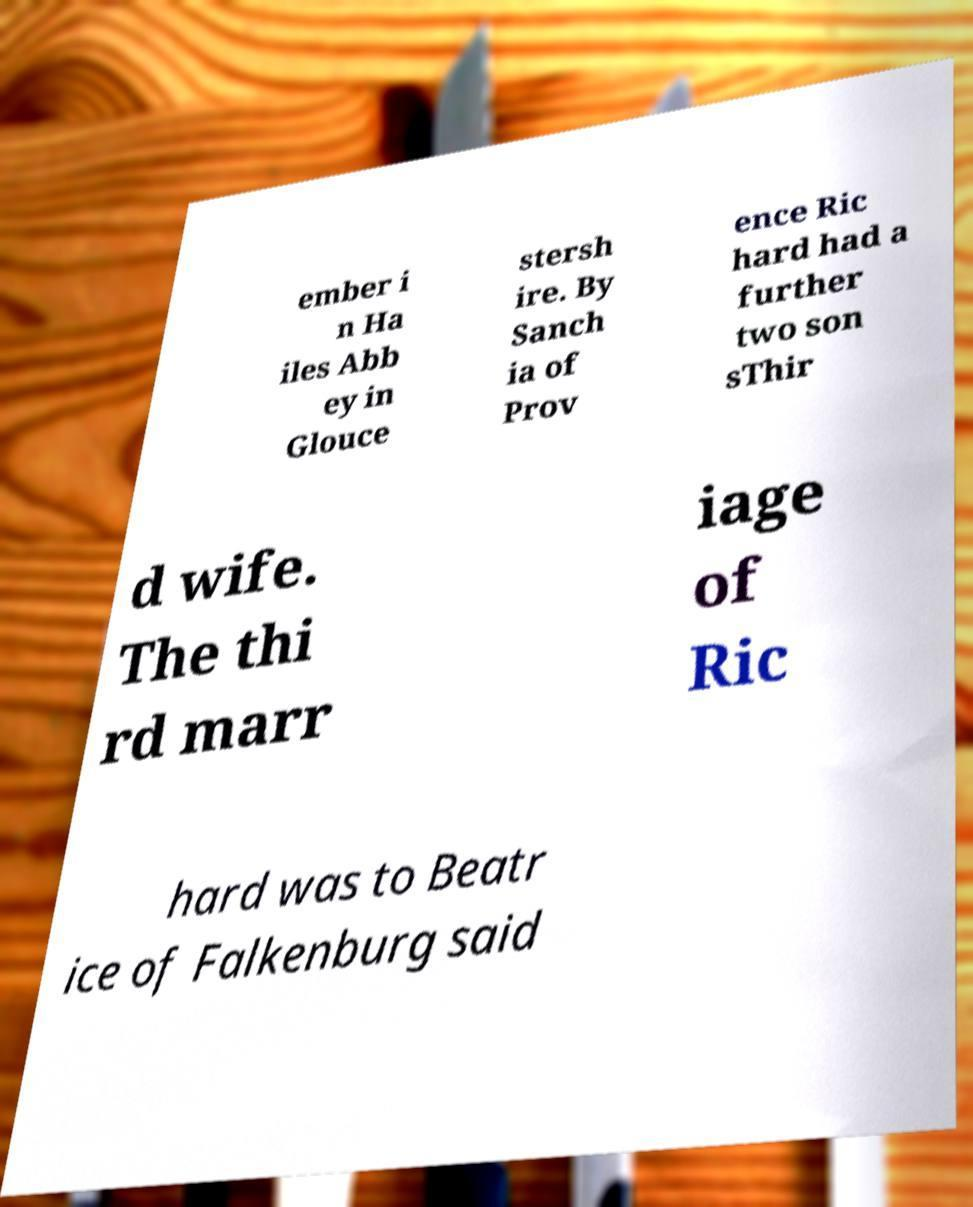Can you read and provide the text displayed in the image?This photo seems to have some interesting text. Can you extract and type it out for me? ember i n Ha iles Abb ey in Glouce stersh ire. By Sanch ia of Prov ence Ric hard had a further two son sThir d wife. The thi rd marr iage of Ric hard was to Beatr ice of Falkenburg said 